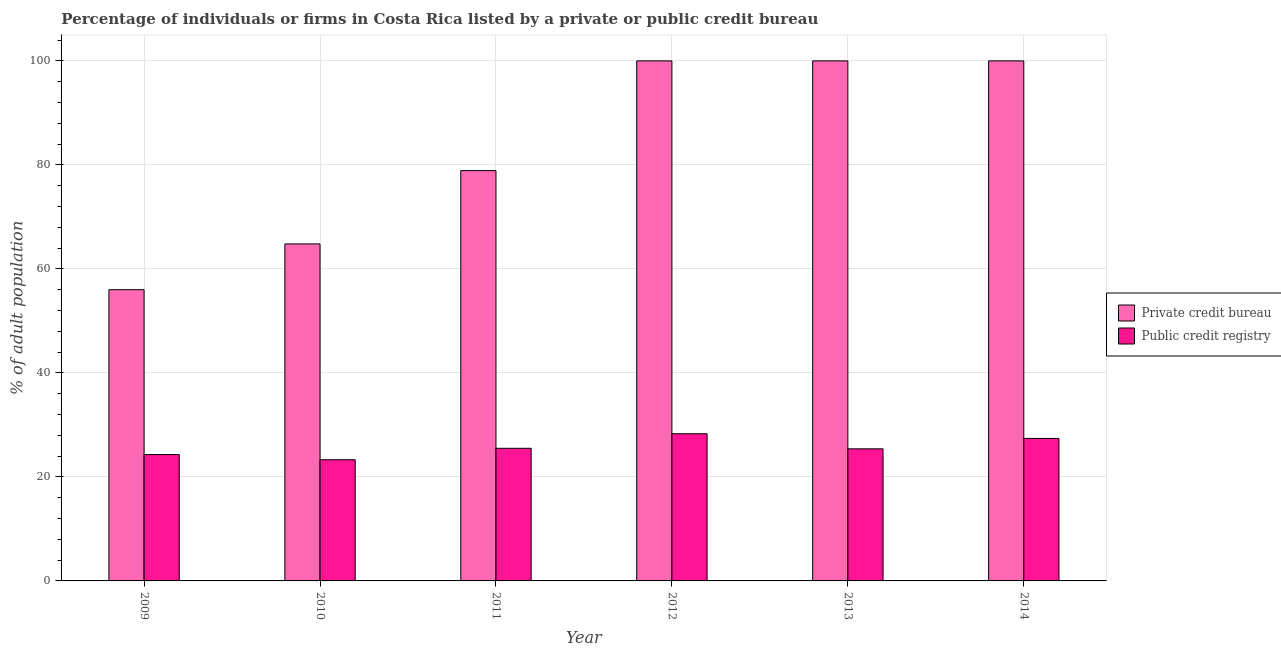How many groups of bars are there?
Your answer should be compact. 6. Are the number of bars per tick equal to the number of legend labels?
Provide a short and direct response. Yes. In how many cases, is the number of bars for a given year not equal to the number of legend labels?
Your answer should be compact. 0. What is the percentage of firms listed by public credit bureau in 2014?
Offer a very short reply. 27.4. Across all years, what is the maximum percentage of firms listed by public credit bureau?
Make the answer very short. 28.3. In which year was the percentage of firms listed by private credit bureau minimum?
Your answer should be very brief. 2009. What is the total percentage of firms listed by private credit bureau in the graph?
Your response must be concise. 499.7. What is the difference between the percentage of firms listed by public credit bureau in 2009 and that in 2011?
Ensure brevity in your answer.  -1.2. What is the difference between the percentage of firms listed by private credit bureau in 2009 and the percentage of firms listed by public credit bureau in 2014?
Keep it short and to the point. -44. What is the average percentage of firms listed by public credit bureau per year?
Keep it short and to the point. 25.7. What is the ratio of the percentage of firms listed by public credit bureau in 2009 to that in 2010?
Keep it short and to the point. 1.04. What is the difference between the highest and the lowest percentage of firms listed by private credit bureau?
Provide a succinct answer. 44. In how many years, is the percentage of firms listed by public credit bureau greater than the average percentage of firms listed by public credit bureau taken over all years?
Provide a succinct answer. 2. Is the sum of the percentage of firms listed by public credit bureau in 2010 and 2012 greater than the maximum percentage of firms listed by private credit bureau across all years?
Your answer should be compact. Yes. What does the 2nd bar from the left in 2010 represents?
Give a very brief answer. Public credit registry. What does the 2nd bar from the right in 2011 represents?
Your response must be concise. Private credit bureau. How many bars are there?
Make the answer very short. 12. Are all the bars in the graph horizontal?
Provide a short and direct response. No. Are the values on the major ticks of Y-axis written in scientific E-notation?
Provide a short and direct response. No. How are the legend labels stacked?
Your response must be concise. Vertical. What is the title of the graph?
Provide a short and direct response. Percentage of individuals or firms in Costa Rica listed by a private or public credit bureau. What is the label or title of the Y-axis?
Ensure brevity in your answer.  % of adult population. What is the % of adult population in Private credit bureau in 2009?
Offer a very short reply. 56. What is the % of adult population in Public credit registry in 2009?
Your answer should be compact. 24.3. What is the % of adult population in Private credit bureau in 2010?
Offer a very short reply. 64.8. What is the % of adult population of Public credit registry in 2010?
Offer a very short reply. 23.3. What is the % of adult population of Private credit bureau in 2011?
Give a very brief answer. 78.9. What is the % of adult population of Public credit registry in 2011?
Your answer should be compact. 25.5. What is the % of adult population of Public credit registry in 2012?
Your response must be concise. 28.3. What is the % of adult population of Public credit registry in 2013?
Offer a terse response. 25.4. What is the % of adult population of Private credit bureau in 2014?
Keep it short and to the point. 100. What is the % of adult population of Public credit registry in 2014?
Give a very brief answer. 27.4. Across all years, what is the maximum % of adult population in Private credit bureau?
Give a very brief answer. 100. Across all years, what is the maximum % of adult population of Public credit registry?
Provide a short and direct response. 28.3. Across all years, what is the minimum % of adult population in Private credit bureau?
Give a very brief answer. 56. Across all years, what is the minimum % of adult population of Public credit registry?
Ensure brevity in your answer.  23.3. What is the total % of adult population of Private credit bureau in the graph?
Your response must be concise. 499.7. What is the total % of adult population of Public credit registry in the graph?
Offer a very short reply. 154.2. What is the difference between the % of adult population in Private credit bureau in 2009 and that in 2011?
Offer a terse response. -22.9. What is the difference between the % of adult population in Private credit bureau in 2009 and that in 2012?
Your answer should be compact. -44. What is the difference between the % of adult population of Public credit registry in 2009 and that in 2012?
Keep it short and to the point. -4. What is the difference between the % of adult population of Private credit bureau in 2009 and that in 2013?
Make the answer very short. -44. What is the difference between the % of adult population of Public credit registry in 2009 and that in 2013?
Offer a very short reply. -1.1. What is the difference between the % of adult population of Private credit bureau in 2009 and that in 2014?
Make the answer very short. -44. What is the difference between the % of adult population of Public credit registry in 2009 and that in 2014?
Your response must be concise. -3.1. What is the difference between the % of adult population in Private credit bureau in 2010 and that in 2011?
Ensure brevity in your answer.  -14.1. What is the difference between the % of adult population of Public credit registry in 2010 and that in 2011?
Provide a succinct answer. -2.2. What is the difference between the % of adult population in Private credit bureau in 2010 and that in 2012?
Your answer should be compact. -35.2. What is the difference between the % of adult population in Private credit bureau in 2010 and that in 2013?
Make the answer very short. -35.2. What is the difference between the % of adult population in Public credit registry in 2010 and that in 2013?
Keep it short and to the point. -2.1. What is the difference between the % of adult population in Private credit bureau in 2010 and that in 2014?
Your response must be concise. -35.2. What is the difference between the % of adult population in Public credit registry in 2010 and that in 2014?
Your response must be concise. -4.1. What is the difference between the % of adult population of Private credit bureau in 2011 and that in 2012?
Offer a terse response. -21.1. What is the difference between the % of adult population of Public credit registry in 2011 and that in 2012?
Offer a terse response. -2.8. What is the difference between the % of adult population of Private credit bureau in 2011 and that in 2013?
Offer a terse response. -21.1. What is the difference between the % of adult population of Private credit bureau in 2011 and that in 2014?
Provide a short and direct response. -21.1. What is the difference between the % of adult population of Public credit registry in 2011 and that in 2014?
Your response must be concise. -1.9. What is the difference between the % of adult population in Public credit registry in 2012 and that in 2013?
Your response must be concise. 2.9. What is the difference between the % of adult population of Public credit registry in 2012 and that in 2014?
Make the answer very short. 0.9. What is the difference between the % of adult population of Public credit registry in 2013 and that in 2014?
Make the answer very short. -2. What is the difference between the % of adult population in Private credit bureau in 2009 and the % of adult population in Public credit registry in 2010?
Provide a short and direct response. 32.7. What is the difference between the % of adult population of Private credit bureau in 2009 and the % of adult population of Public credit registry in 2011?
Ensure brevity in your answer.  30.5. What is the difference between the % of adult population of Private credit bureau in 2009 and the % of adult population of Public credit registry in 2012?
Offer a terse response. 27.7. What is the difference between the % of adult population of Private credit bureau in 2009 and the % of adult population of Public credit registry in 2013?
Make the answer very short. 30.6. What is the difference between the % of adult population of Private credit bureau in 2009 and the % of adult population of Public credit registry in 2014?
Provide a succinct answer. 28.6. What is the difference between the % of adult population in Private credit bureau in 2010 and the % of adult population in Public credit registry in 2011?
Ensure brevity in your answer.  39.3. What is the difference between the % of adult population of Private credit bureau in 2010 and the % of adult population of Public credit registry in 2012?
Your answer should be very brief. 36.5. What is the difference between the % of adult population in Private credit bureau in 2010 and the % of adult population in Public credit registry in 2013?
Provide a short and direct response. 39.4. What is the difference between the % of adult population of Private credit bureau in 2010 and the % of adult population of Public credit registry in 2014?
Keep it short and to the point. 37.4. What is the difference between the % of adult population of Private credit bureau in 2011 and the % of adult population of Public credit registry in 2012?
Keep it short and to the point. 50.6. What is the difference between the % of adult population of Private credit bureau in 2011 and the % of adult population of Public credit registry in 2013?
Provide a succinct answer. 53.5. What is the difference between the % of adult population of Private credit bureau in 2011 and the % of adult population of Public credit registry in 2014?
Provide a short and direct response. 51.5. What is the difference between the % of adult population in Private credit bureau in 2012 and the % of adult population in Public credit registry in 2013?
Provide a succinct answer. 74.6. What is the difference between the % of adult population in Private credit bureau in 2012 and the % of adult population in Public credit registry in 2014?
Your answer should be compact. 72.6. What is the difference between the % of adult population of Private credit bureau in 2013 and the % of adult population of Public credit registry in 2014?
Your answer should be very brief. 72.6. What is the average % of adult population in Private credit bureau per year?
Your answer should be compact. 83.28. What is the average % of adult population in Public credit registry per year?
Keep it short and to the point. 25.7. In the year 2009, what is the difference between the % of adult population of Private credit bureau and % of adult population of Public credit registry?
Keep it short and to the point. 31.7. In the year 2010, what is the difference between the % of adult population of Private credit bureau and % of adult population of Public credit registry?
Offer a terse response. 41.5. In the year 2011, what is the difference between the % of adult population of Private credit bureau and % of adult population of Public credit registry?
Your response must be concise. 53.4. In the year 2012, what is the difference between the % of adult population in Private credit bureau and % of adult population in Public credit registry?
Keep it short and to the point. 71.7. In the year 2013, what is the difference between the % of adult population of Private credit bureau and % of adult population of Public credit registry?
Keep it short and to the point. 74.6. In the year 2014, what is the difference between the % of adult population of Private credit bureau and % of adult population of Public credit registry?
Your answer should be very brief. 72.6. What is the ratio of the % of adult population of Private credit bureau in 2009 to that in 2010?
Offer a very short reply. 0.86. What is the ratio of the % of adult population in Public credit registry in 2009 to that in 2010?
Make the answer very short. 1.04. What is the ratio of the % of adult population in Private credit bureau in 2009 to that in 2011?
Make the answer very short. 0.71. What is the ratio of the % of adult population in Public credit registry in 2009 to that in 2011?
Offer a terse response. 0.95. What is the ratio of the % of adult population in Private credit bureau in 2009 to that in 2012?
Your answer should be very brief. 0.56. What is the ratio of the % of adult population in Public credit registry in 2009 to that in 2012?
Your response must be concise. 0.86. What is the ratio of the % of adult population in Private credit bureau in 2009 to that in 2013?
Your answer should be very brief. 0.56. What is the ratio of the % of adult population in Public credit registry in 2009 to that in 2013?
Make the answer very short. 0.96. What is the ratio of the % of adult population of Private credit bureau in 2009 to that in 2014?
Ensure brevity in your answer.  0.56. What is the ratio of the % of adult population in Public credit registry in 2009 to that in 2014?
Your answer should be compact. 0.89. What is the ratio of the % of adult population in Private credit bureau in 2010 to that in 2011?
Provide a succinct answer. 0.82. What is the ratio of the % of adult population of Public credit registry in 2010 to that in 2011?
Offer a terse response. 0.91. What is the ratio of the % of adult population in Private credit bureau in 2010 to that in 2012?
Offer a very short reply. 0.65. What is the ratio of the % of adult population in Public credit registry in 2010 to that in 2012?
Give a very brief answer. 0.82. What is the ratio of the % of adult population in Private credit bureau in 2010 to that in 2013?
Offer a very short reply. 0.65. What is the ratio of the % of adult population in Public credit registry in 2010 to that in 2013?
Keep it short and to the point. 0.92. What is the ratio of the % of adult population of Private credit bureau in 2010 to that in 2014?
Offer a very short reply. 0.65. What is the ratio of the % of adult population of Public credit registry in 2010 to that in 2014?
Offer a very short reply. 0.85. What is the ratio of the % of adult population of Private credit bureau in 2011 to that in 2012?
Offer a terse response. 0.79. What is the ratio of the % of adult population of Public credit registry in 2011 to that in 2012?
Offer a very short reply. 0.9. What is the ratio of the % of adult population in Private credit bureau in 2011 to that in 2013?
Provide a short and direct response. 0.79. What is the ratio of the % of adult population in Private credit bureau in 2011 to that in 2014?
Your response must be concise. 0.79. What is the ratio of the % of adult population of Public credit registry in 2011 to that in 2014?
Your answer should be compact. 0.93. What is the ratio of the % of adult population in Public credit registry in 2012 to that in 2013?
Keep it short and to the point. 1.11. What is the ratio of the % of adult population of Public credit registry in 2012 to that in 2014?
Make the answer very short. 1.03. What is the ratio of the % of adult population in Private credit bureau in 2013 to that in 2014?
Ensure brevity in your answer.  1. What is the ratio of the % of adult population in Public credit registry in 2013 to that in 2014?
Offer a terse response. 0.93. What is the difference between the highest and the second highest % of adult population in Private credit bureau?
Ensure brevity in your answer.  0. What is the difference between the highest and the lowest % of adult population in Private credit bureau?
Ensure brevity in your answer.  44. 